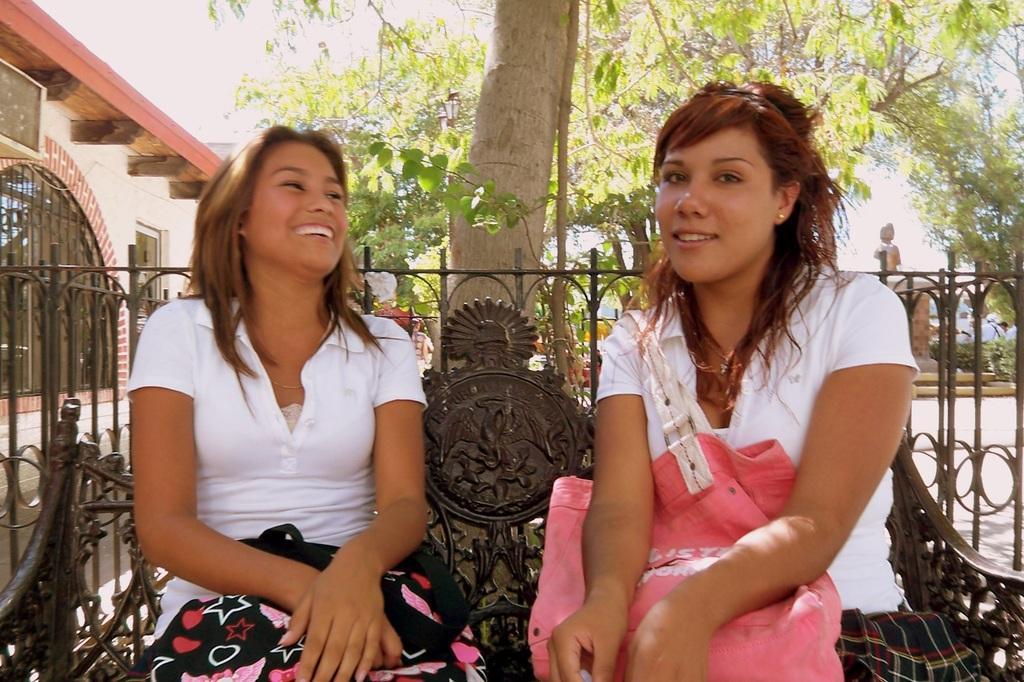Can you describe this image briefly? In the middle of the image two women are sitting on a bench and smiling. Behind them there is fencing. Behind the fencing there are some trees, buildings and plants. Behind them few people are standing. 